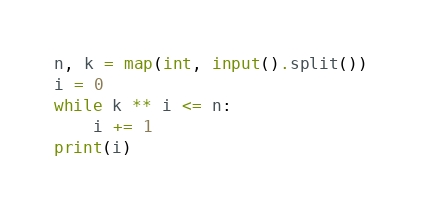<code> <loc_0><loc_0><loc_500><loc_500><_Python_>n, k = map(int, input().split())
i = 0
while k ** i <= n:
    i += 1
print(i)</code> 